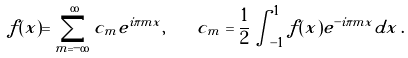Convert formula to latex. <formula><loc_0><loc_0><loc_500><loc_500>f ( x ) = \sum _ { m = - \infty } ^ { \infty } c _ { m } e ^ { i \pi m x } , \quad c _ { m } = \frac { 1 } { 2 } \int _ { - 1 } ^ { 1 } f ( x ) e ^ { - i \pi m x } d x \, .</formula> 